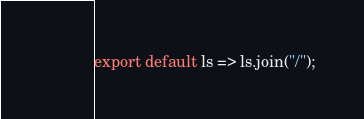<code> <loc_0><loc_0><loc_500><loc_500><_JavaScript_>export default ls => ls.join("/");
</code> 